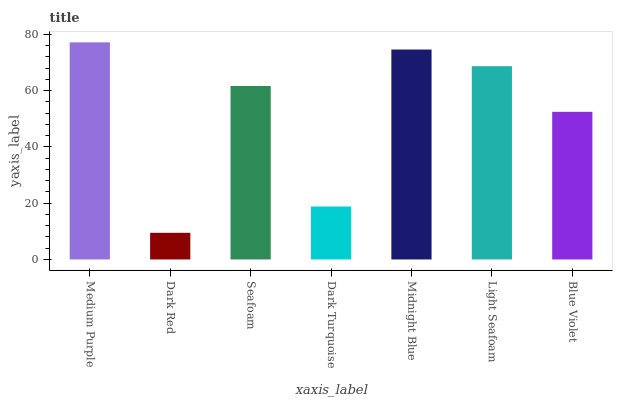Is Dark Red the minimum?
Answer yes or no. Yes. Is Medium Purple the maximum?
Answer yes or no. Yes. Is Seafoam the minimum?
Answer yes or no. No. Is Seafoam the maximum?
Answer yes or no. No. Is Seafoam greater than Dark Red?
Answer yes or no. Yes. Is Dark Red less than Seafoam?
Answer yes or no. Yes. Is Dark Red greater than Seafoam?
Answer yes or no. No. Is Seafoam less than Dark Red?
Answer yes or no. No. Is Seafoam the high median?
Answer yes or no. Yes. Is Seafoam the low median?
Answer yes or no. Yes. Is Medium Purple the high median?
Answer yes or no. No. Is Blue Violet the low median?
Answer yes or no. No. 